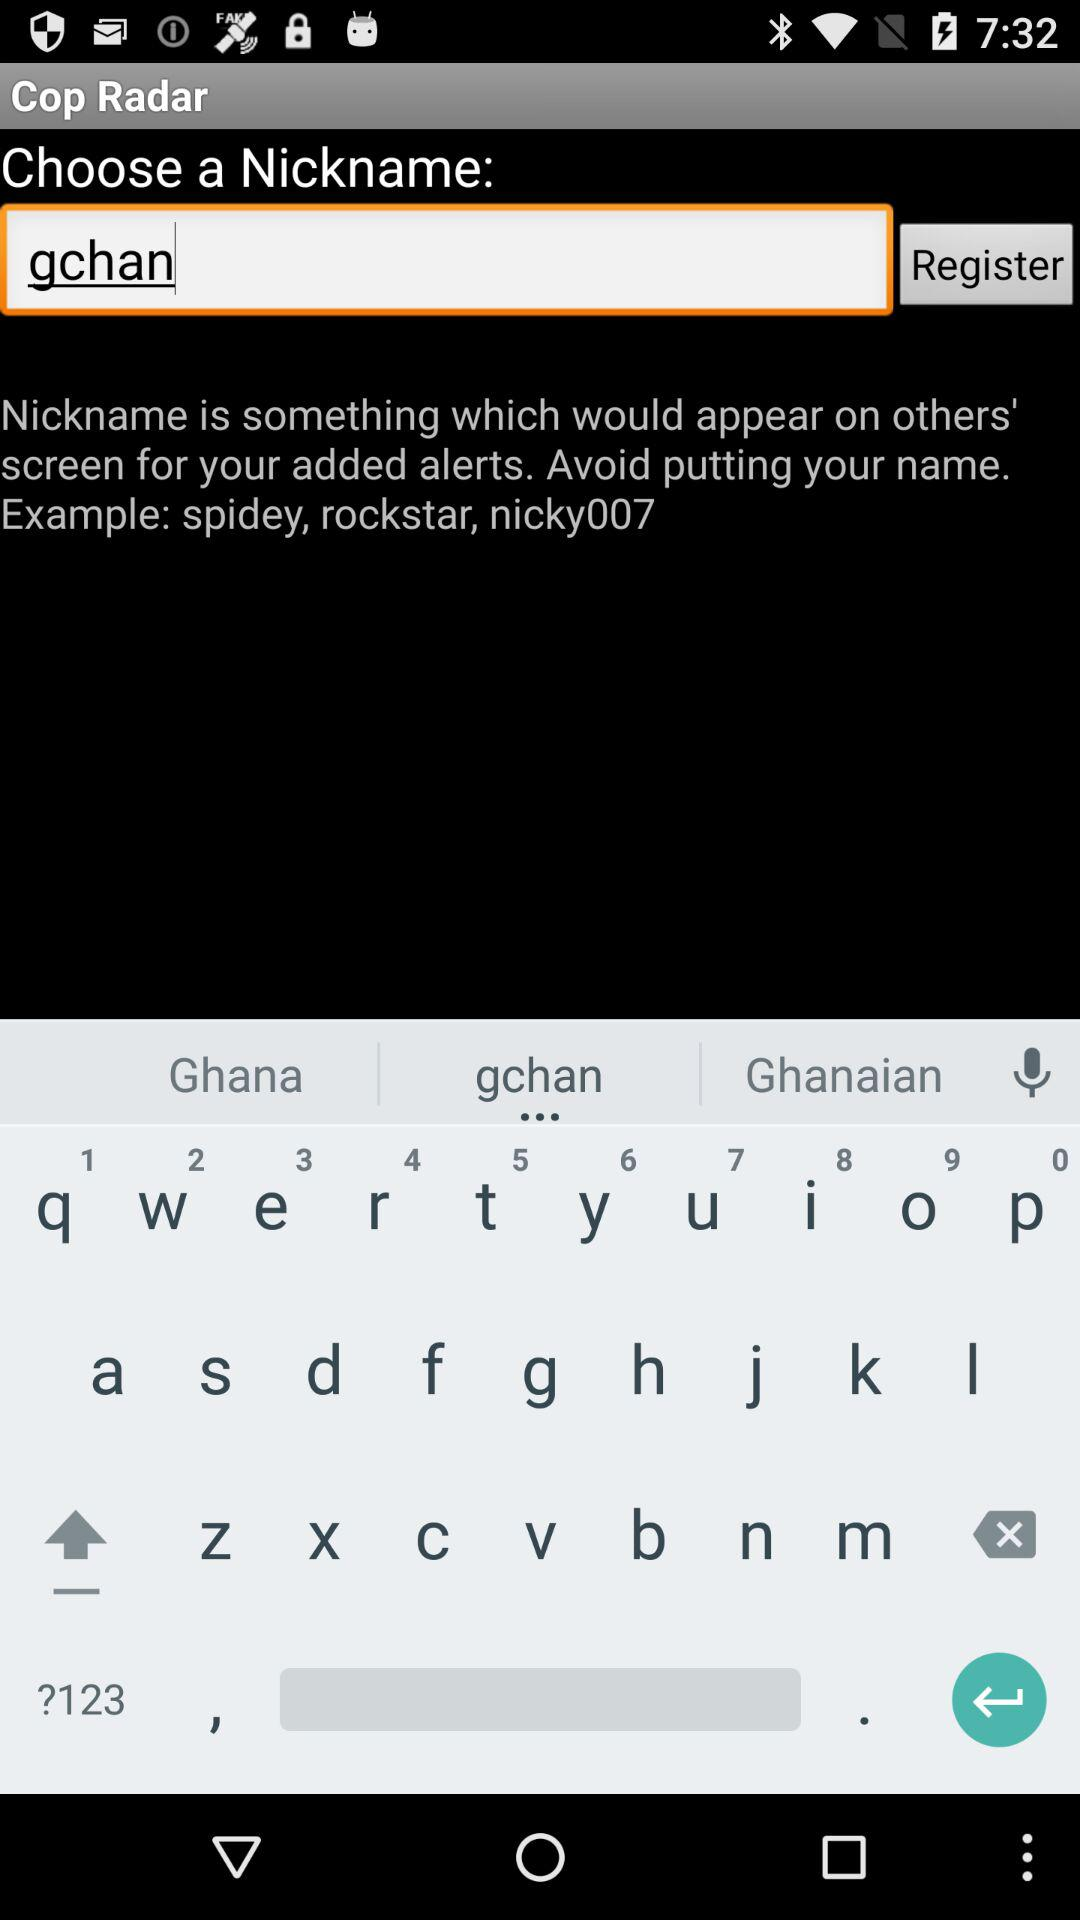What is the nickname? The nickname is gchan. 